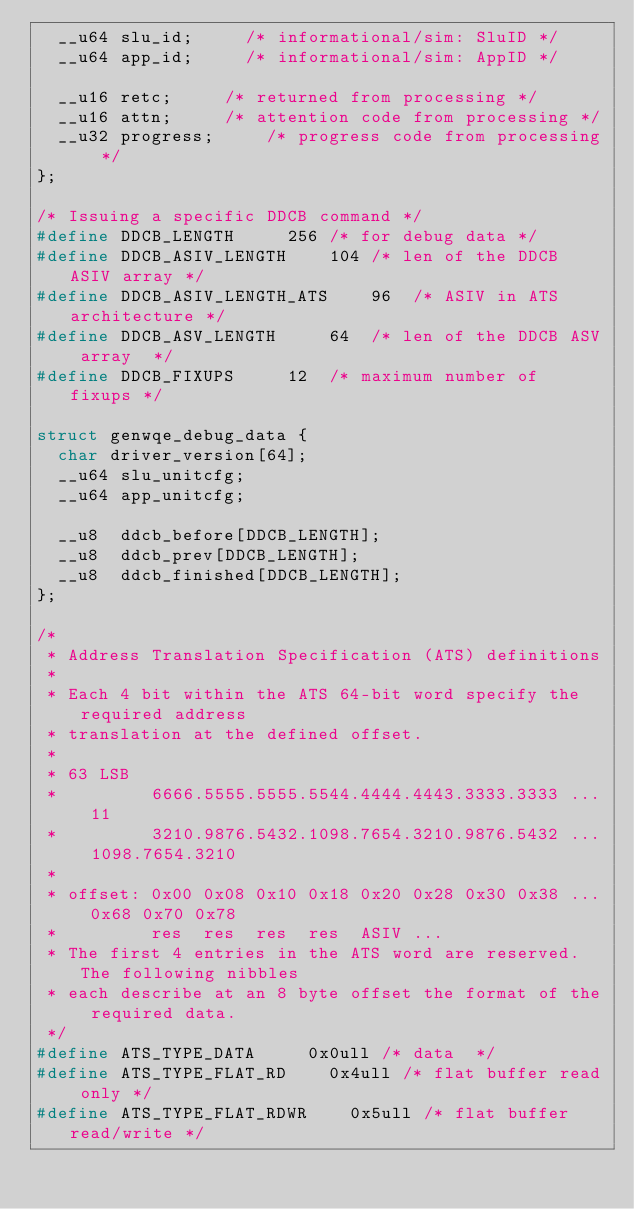<code> <loc_0><loc_0><loc_500><loc_500><_C_>	__u64 slu_id;			/* informational/sim: SluID */
	__u64 app_id;			/* informational/sim: AppID */

	__u16 retc;			/* returned from processing */
	__u16 attn;			/* attention code from processing */
	__u32 progress;			/* progress code from processing */
};

/* Issuing a specific DDCB command */
#define DDCB_LENGTH			256 /* for debug data */
#define DDCB_ASIV_LENGTH		104 /* len of the DDCB ASIV array */
#define DDCB_ASIV_LENGTH_ATS		96  /* ASIV in ATS architecture */
#define DDCB_ASV_LENGTH			64  /* len of the DDCB ASV array  */
#define DDCB_FIXUPS			12  /* maximum number of fixups */

struct genwqe_debug_data {
	char driver_version[64];
	__u64 slu_unitcfg;
	__u64 app_unitcfg;

	__u8  ddcb_before[DDCB_LENGTH];
	__u8  ddcb_prev[DDCB_LENGTH];
	__u8  ddcb_finished[DDCB_LENGTH];
};

/*
 * Address Translation Specification (ATS) definitions
 *
 * Each 4 bit within the ATS 64-bit word specify the required address
 * translation at the defined offset.
 *
 * 63 LSB
 *         6666.5555.5555.5544.4444.4443.3333.3333 ... 11
 *         3210.9876.5432.1098.7654.3210.9876.5432 ... 1098.7654.3210
 *
 * offset: 0x00 0x08 0x10 0x18 0x20 0x28 0x30 0x38 ... 0x68 0x70 0x78
 *         res  res  res  res  ASIV ...
 * The first 4 entries in the ATS word are reserved. The following nibbles
 * each describe at an 8 byte offset the format of the required data.
 */
#define ATS_TYPE_DATA			0x0ull /* data  */
#define ATS_TYPE_FLAT_RD		0x4ull /* flat buffer read only */
#define ATS_TYPE_FLAT_RDWR		0x5ull /* flat buffer read/write */</code> 